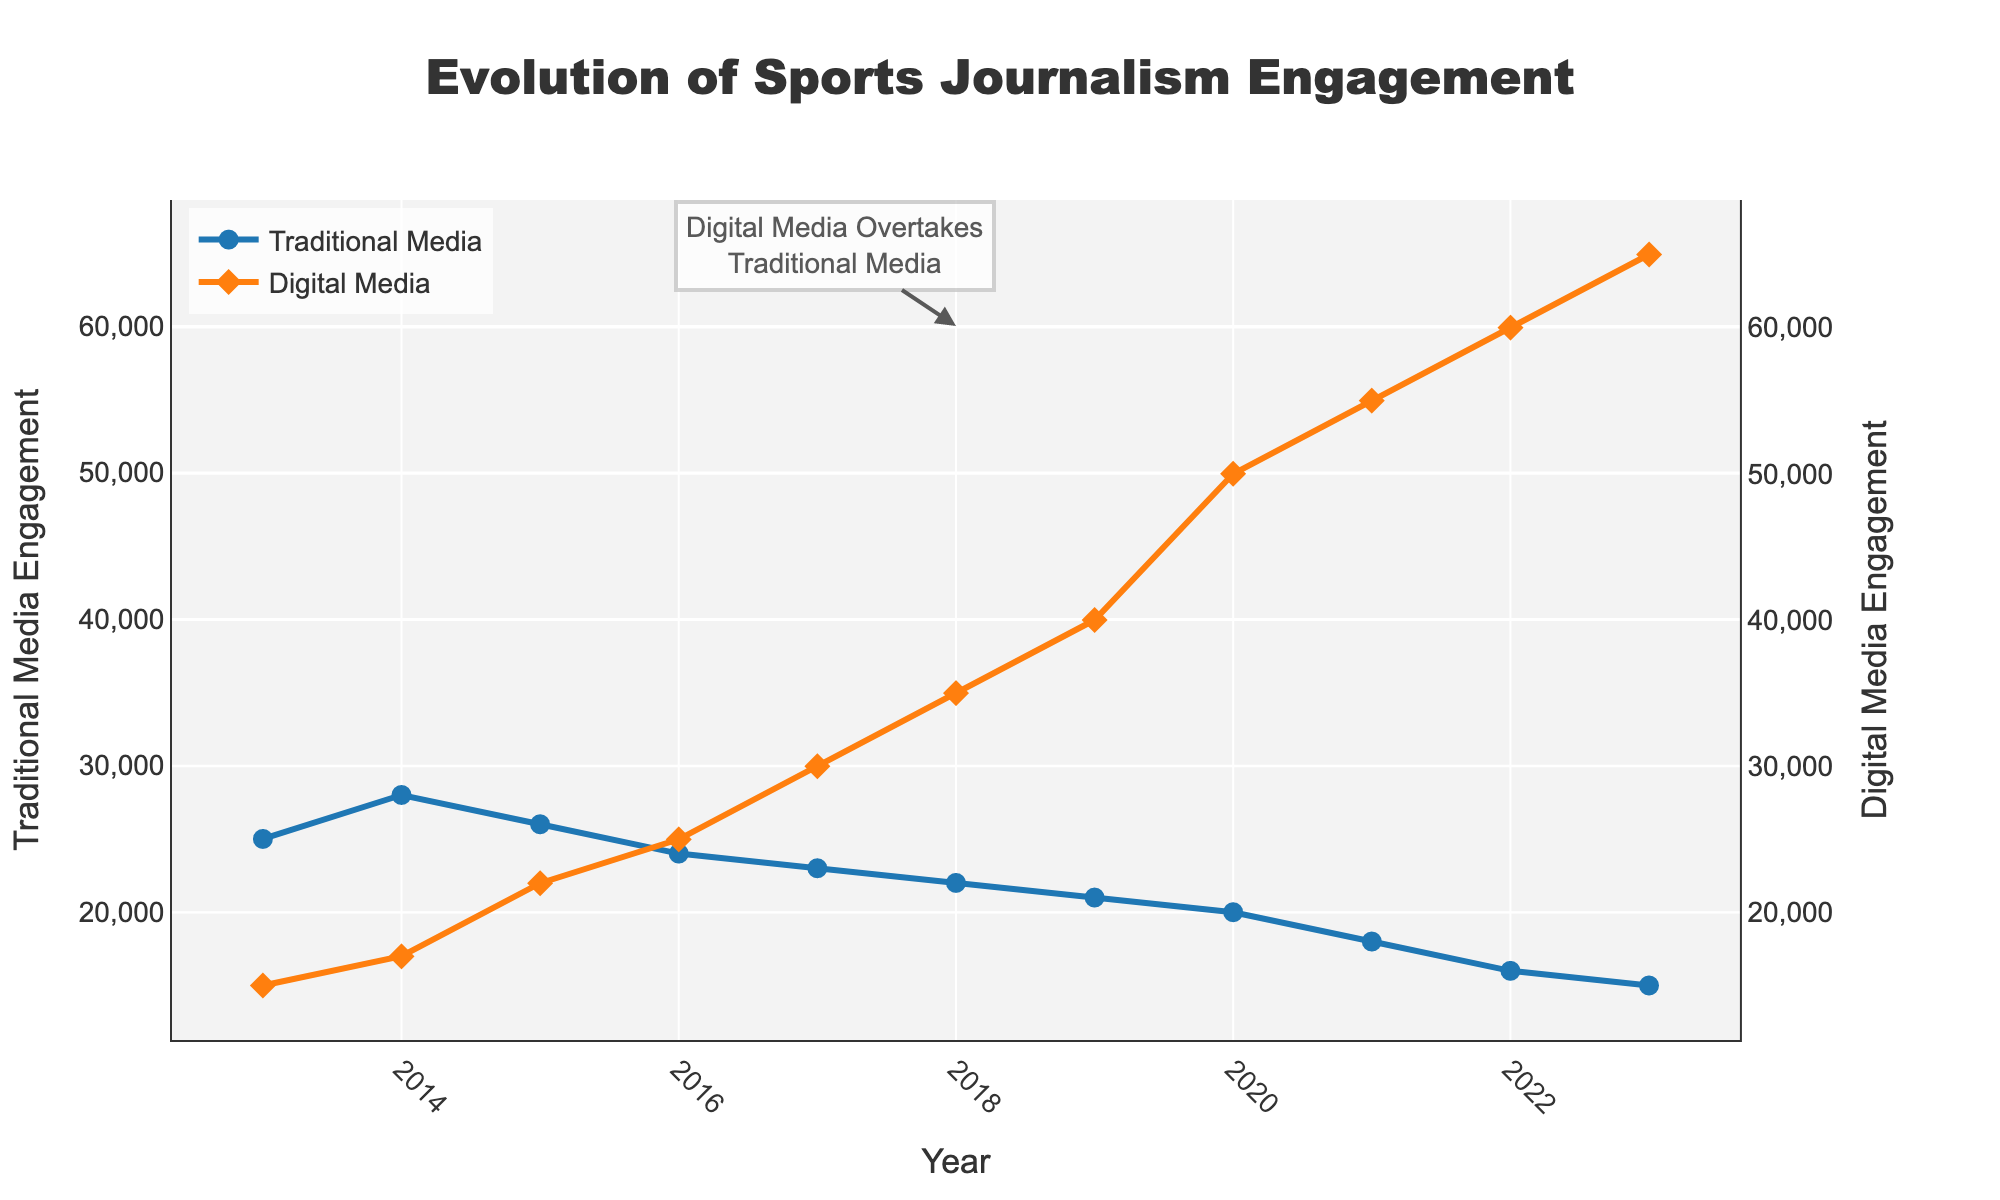How many data points are representing the Digital Media Engagement over the past 10 years? The figure shows engagement points from 2013 to 2023. Therefore, counting each year's data point gives us 11 points.
Answer: 11 What does the annotation in the figure indicate? The annotation text "Digital Media Overtakes Traditional Media" with an arrow pointing shows that in 2018, digital media engagement first surpassed traditional media engagement.
Answer: Digital media overtook traditional media in 2018 By how much did the traditional media engagement decrease from 2013 to 2023? In 2013, traditional media engagement was 25,000, and in 2023 it was 15,000. The decrease is 25,000 - 15,000, which is 10,000.
Answer: 10,000 Which year showed the highest engagement for Digital Media, and what was the value? On the y-axis of the figure, locate the highest point for Digital Media Engagement. In 2023, digital media engagement reached 65,000, which is the highest value shown.
Answer: 2023, 65,000 What was the overall trend for Traditional Media Engagement over the past decade? Observing the trend line for Traditional Media Engagement, it has steadily decreased from 25,000 in 2013 to 15,000 in 2023.
Answer: Decreasing What is the approximate slope of the Digital Media Engagement curve from 2013 to 2023? To find the slope, use the formula (change in y) / (change in x). The change in y is 65,000 - 15,000, and the change in x is 2023 - 2013, so the slope is (65,000 - 15,000) / (2023 - 2013) = 50,000 / 10 = 5,000.
Answer: 5,000 Compare the engagement rates of Traditional Media vs. Digital Media in 2017. Which was higher and by how much? In 2017, traditional media engagement was 23,000, and digital media engagement was 30,000. Digital media was higher by 30,000 - 23,000 = 7,000.
Answer: Digital Media, by 7,000 In which year did Traditional Media Engagement first drop below 20,000? The graph line for Traditional Media Engagement drops below the 20,000 mark in 2021.
Answer: 2021 What is the main insight regarding sports journalism engagement from the figure? The main insight is that Digital Media Engagement has significantly increased over the past decade, surpassing Traditional Media Engagement in 2018 and continuing to rise, while Traditional Media Engagement has steadily decreased.
Answer: Digital media has risen past traditional media How many years had a Digital Media Engagement that exceeded 40,000? Based on the figure, Digital Media Engagement exceeded 40,000 in the years 2019, 2020, 2021, 2022, and 2023, totaling 5 years.
Answer: 5 